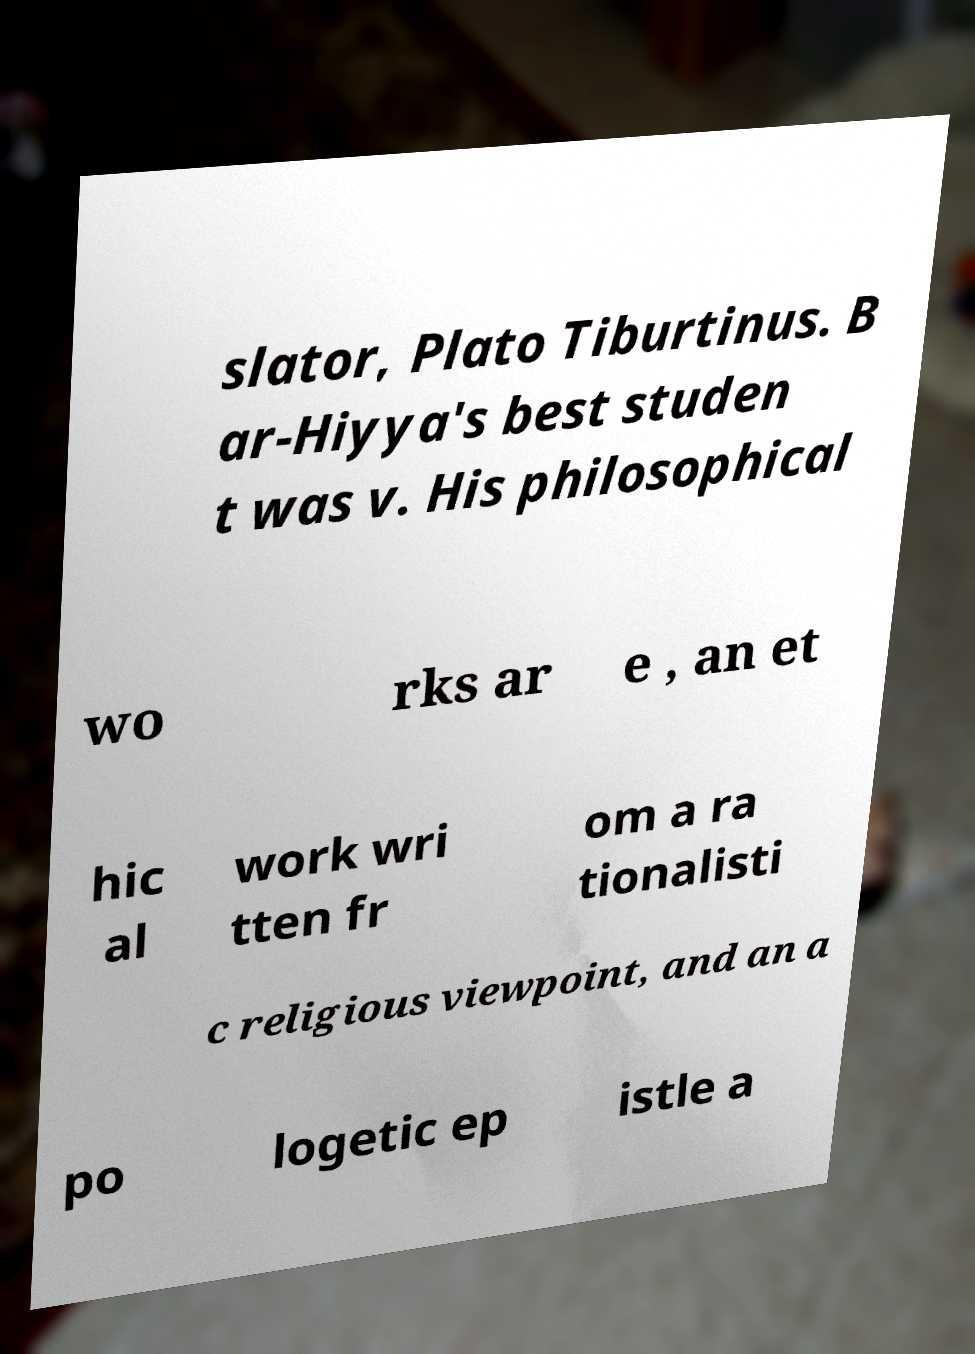Can you accurately transcribe the text from the provided image for me? slator, Plato Tiburtinus. B ar-Hiyya's best studen t was v. His philosophical wo rks ar e , an et hic al work wri tten fr om a ra tionalisti c religious viewpoint, and an a po logetic ep istle a 